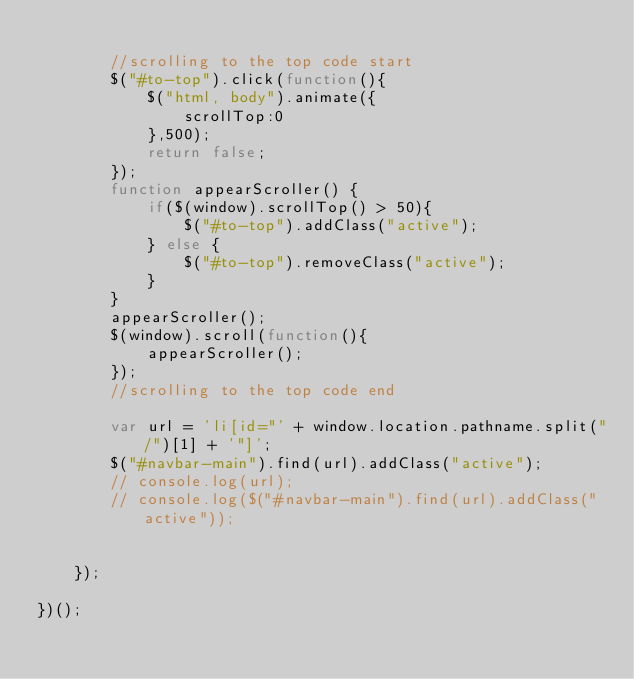Convert code to text. <code><loc_0><loc_0><loc_500><loc_500><_JavaScript_>
        //scrolling to the top code start
        $("#to-top").click(function(){
            $("html, body").animate({
                scrollTop:0
            },500);
            return false;
        });
        function appearScroller() {
            if($(window).scrollTop() > 50){
                $("#to-top").addClass("active");
            } else {
                $("#to-top").removeClass("active");
            }
        }
        appearScroller();
        $(window).scroll(function(){
            appearScroller();
        });
        //scrolling to the top code end

        var url = 'li[id="' + window.location.pathname.split("/")[1] + '"]';
        $("#navbar-main").find(url).addClass("active");
        // console.log(url);
        // console.log($("#navbar-main").find(url).addClass("active"));
     

    });

})();</code> 